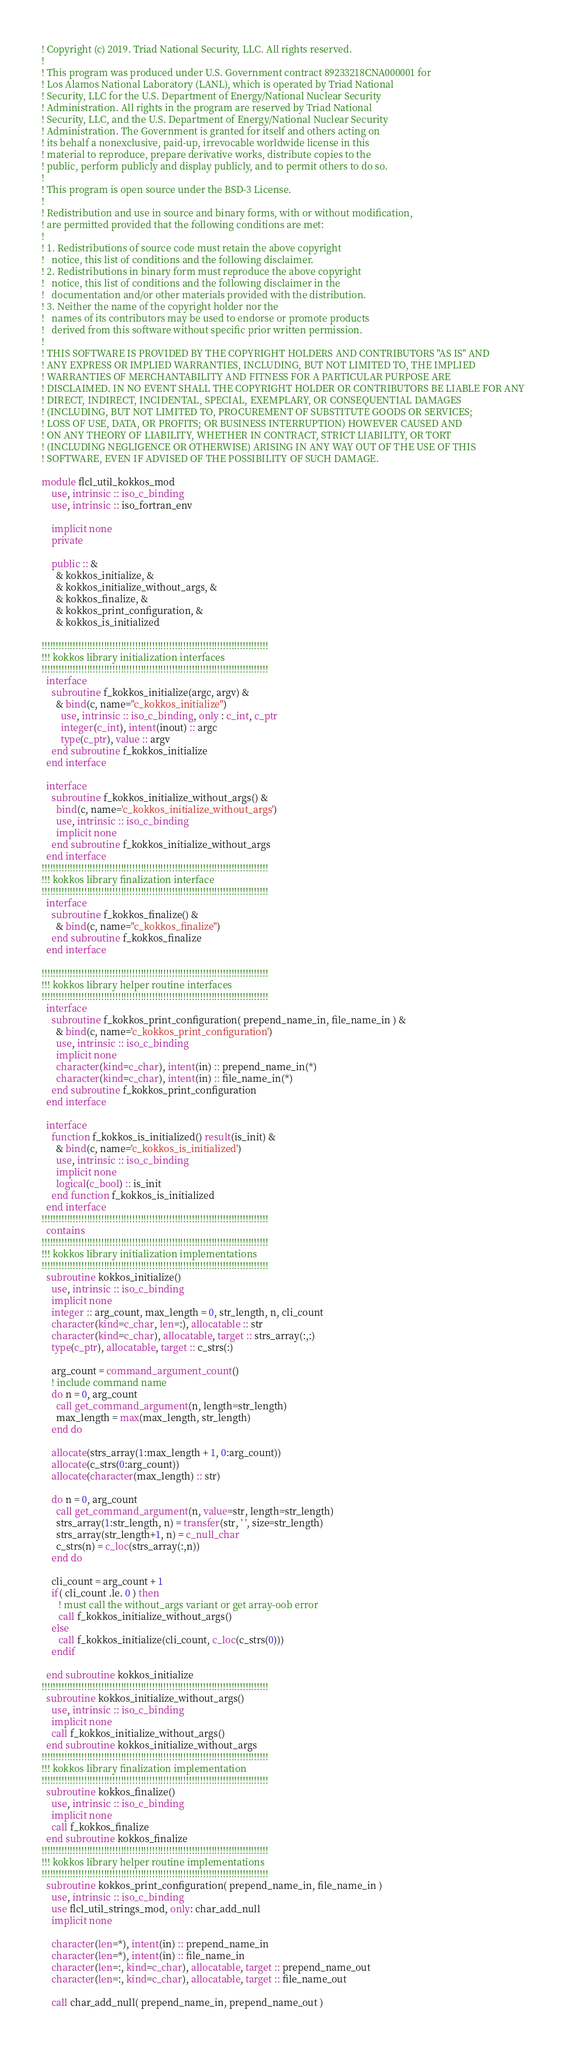<code> <loc_0><loc_0><loc_500><loc_500><_FORTRAN_>! Copyright (c) 2019. Triad National Security, LLC. All rights reserved.
!
! This program was produced under U.S. Government contract 89233218CNA000001 for
! Los Alamos National Laboratory (LANL), which is operated by Triad National
! Security, LLC for the U.S. Department of Energy/National Nuclear Security
! Administration. All rights in the program are reserved by Triad National
! Security, LLC, and the U.S. Department of Energy/National Nuclear Security
! Administration. The Government is granted for itself and others acting on
! its behalf a nonexclusive, paid-up, irrevocable worldwide license in this
! material to reproduce, prepare derivative works, distribute copies to the
! public, perform publicly and display publicly, and to permit others to do so.
!
! This program is open source under the BSD-3 License.
!
! Redistribution and use in source and binary forms, with or without modification,
! are permitted provided that the following conditions are met:
!
! 1. Redistributions of source code must retain the above copyright
!   notice, this list of conditions and the following disclaimer.
! 2. Redistributions in binary form must reproduce the above copyright
!   notice, this list of conditions and the following disclaimer in the
!   documentation and/or other materials provided with the distribution.
! 3. Neither the name of the copyright holder nor the
!   names of its contributors may be used to endorse or promote products
!   derived from this software without specific prior written permission.
!
! THIS SOFTWARE IS PROVIDED BY THE COPYRIGHT HOLDERS AND CONTRIBUTORS "AS IS" AND
! ANY EXPRESS OR IMPLIED WARRANTIES, INCLUDING, BUT NOT LIMITED TO, THE IMPLIED
! WARRANTIES OF MERCHANTABILITY AND FITNESS FOR A PARTICULAR PURPOSE ARE
! DISCLAIMED. IN NO EVENT SHALL THE COPYRIGHT HOLDER OR CONTRIBUTORS BE LIABLE FOR ANY
! DIRECT, INDIRECT, INCIDENTAL, SPECIAL, EXEMPLARY, OR CONSEQUENTIAL DAMAGES
! (INCLUDING, BUT NOT LIMITED TO, PROCUREMENT OF SUBSTITUTE GOODS OR SERVICES;
! LOSS OF USE, DATA, OR PROFITS; OR BUSINESS INTERRUPTION) HOWEVER CAUSED AND
! ON ANY THEORY OF LIABILITY, WHETHER IN CONTRACT, STRICT LIABILITY, OR TORT
! (INCLUDING NEGLIGENCE OR OTHERWISE) ARISING IN ANY WAY OUT OF THE USE OF THIS
! SOFTWARE, EVEN IF ADVISED OF THE POSSIBILITY OF SUCH DAMAGE.

module flcl_util_kokkos_mod
    use, intrinsic :: iso_c_binding
    use, intrinsic :: iso_fortran_env
    
    implicit none
    private

    public :: &
      & kokkos_initialize, &
      & kokkos_initialize_without_args, &
      & kokkos_finalize, &
      & kokkos_print_configuration, &
      & kokkos_is_initialized

!!!!!!!!!!!!!!!!!!!!!!!!!!!!!!!!!!!!!!!!!!!!!!!!!!!!!!!!!!!!!!!!!!!!!!!!!!!!!!!!
!!! kokkos library initialization interfaces
!!!!!!!!!!!!!!!!!!!!!!!!!!!!!!!!!!!!!!!!!!!!!!!!!!!!!!!!!!!!!!!!!!!!!!!!!!!!!!!!
  interface
    subroutine f_kokkos_initialize(argc, argv) &
      & bind(c, name="c_kokkos_initialize")
        use, intrinsic :: iso_c_binding, only : c_int, c_ptr
        integer(c_int), intent(inout) :: argc
        type(c_ptr), value :: argv
    end subroutine f_kokkos_initialize
  end interface

  interface
    subroutine f_kokkos_initialize_without_args() &
      bind(c, name='c_kokkos_initialize_without_args')
      use, intrinsic :: iso_c_binding
      implicit none
    end subroutine f_kokkos_initialize_without_args
  end interface
!!!!!!!!!!!!!!!!!!!!!!!!!!!!!!!!!!!!!!!!!!!!!!!!!!!!!!!!!!!!!!!!!!!!!!!!!!!!!!!!
!!! kokkos library finalization interface
!!!!!!!!!!!!!!!!!!!!!!!!!!!!!!!!!!!!!!!!!!!!!!!!!!!!!!!!!!!!!!!!!!!!!!!!!!!!!!!!
  interface
    subroutine f_kokkos_finalize() &
      & bind(c, name="c_kokkos_finalize")  
    end subroutine f_kokkos_finalize
  end interface

!!!!!!!!!!!!!!!!!!!!!!!!!!!!!!!!!!!!!!!!!!!!!!!!!!!!!!!!!!!!!!!!!!!!!!!!!!!!!!!!
!!! kokkos library helper routine interfaces
!!!!!!!!!!!!!!!!!!!!!!!!!!!!!!!!!!!!!!!!!!!!!!!!!!!!!!!!!!!!!!!!!!!!!!!!!!!!!!!!
  interface
    subroutine f_kokkos_print_configuration( prepend_name_in, file_name_in ) &
      & bind(c, name='c_kokkos_print_configuration')
      use, intrinsic :: iso_c_binding
      implicit none
      character(kind=c_char), intent(in) :: prepend_name_in(*)
      character(kind=c_char), intent(in) :: file_name_in(*)
    end subroutine f_kokkos_print_configuration
  end interface

  interface
    function f_kokkos_is_initialized() result(is_init) &
      & bind(c, name='c_kokkos_is_initialized')
      use, intrinsic :: iso_c_binding
      implicit none
      logical(c_bool) :: is_init
    end function f_kokkos_is_initialized
  end interface
!!!!!!!!!!!!!!!!!!!!!!!!!!!!!!!!!!!!!!!!!!!!!!!!!!!!!!!!!!!!!!!!!!!!!!!!!!!!!!!!
  contains
!!!!!!!!!!!!!!!!!!!!!!!!!!!!!!!!!!!!!!!!!!!!!!!!!!!!!!!!!!!!!!!!!!!!!!!!!!!!!!!!
!!! kokkos library initialization implementations
!!!!!!!!!!!!!!!!!!!!!!!!!!!!!!!!!!!!!!!!!!!!!!!!!!!!!!!!!!!!!!!!!!!!!!!!!!!!!!!!
  subroutine kokkos_initialize()
    use, intrinsic :: iso_c_binding
    implicit none
    integer :: arg_count, max_length = 0, str_length, n, cli_count
    character(kind=c_char, len=:), allocatable :: str
    character(kind=c_char), allocatable, target :: strs_array(:,:)
    type(c_ptr), allocatable, target :: c_strs(:)

    arg_count = command_argument_count()
    ! include command name
    do n = 0, arg_count
      call get_command_argument(n, length=str_length)
      max_length = max(max_length, str_length)
    end do

    allocate(strs_array(1:max_length + 1, 0:arg_count))
    allocate(c_strs(0:arg_count))
    allocate(character(max_length) :: str)

    do n = 0, arg_count
      call get_command_argument(n, value=str, length=str_length)
      strs_array(1:str_length, n) = transfer(str, ' ', size=str_length)
      strs_array(str_length+1, n) = c_null_char
      c_strs(n) = c_loc(strs_array(:,n))
    end do

    cli_count = arg_count + 1
    if( cli_count .le. 0 ) then
       ! must call the without_args variant or get array-oob error
       call f_kokkos_initialize_without_args()
    else
       call f_kokkos_initialize(cli_count, c_loc(c_strs(0)))
    endif
       
  end subroutine kokkos_initialize
!!!!!!!!!!!!!!!!!!!!!!!!!!!!!!!!!!!!!!!!!!!!!!!!!!!!!!!!!!!!!!!!!!!!!!!!!!!!!!!!
  subroutine kokkos_initialize_without_args()
    use, intrinsic :: iso_c_binding
    implicit none
    call f_kokkos_initialize_without_args()
  end subroutine kokkos_initialize_without_args
!!!!!!!!!!!!!!!!!!!!!!!!!!!!!!!!!!!!!!!!!!!!!!!!!!!!!!!!!!!!!!!!!!!!!!!!!!!!!!!!
!!! kokkos library finalization implementation
!!!!!!!!!!!!!!!!!!!!!!!!!!!!!!!!!!!!!!!!!!!!!!!!!!!!!!!!!!!!!!!!!!!!!!!!!!!!!!!!
  subroutine kokkos_finalize()
    use, intrinsic :: iso_c_binding
    implicit none
    call f_kokkos_finalize
  end subroutine kokkos_finalize
!!!!!!!!!!!!!!!!!!!!!!!!!!!!!!!!!!!!!!!!!!!!!!!!!!!!!!!!!!!!!!!!!!!!!!!!!!!!!!!!
!!! kokkos library helper routine implementations
!!!!!!!!!!!!!!!!!!!!!!!!!!!!!!!!!!!!!!!!!!!!!!!!!!!!!!!!!!!!!!!!!!!!!!!!!!!!!!!!
  subroutine kokkos_print_configuration( prepend_name_in, file_name_in )
    use, intrinsic :: iso_c_binding
    use flcl_util_strings_mod, only: char_add_null
    implicit none

    character(len=*), intent(in) :: prepend_name_in
    character(len=*), intent(in) :: file_name_in
    character(len=:, kind=c_char), allocatable, target :: prepend_name_out
    character(len=:, kind=c_char), allocatable, target :: file_name_out

    call char_add_null( prepend_name_in, prepend_name_out )</code> 